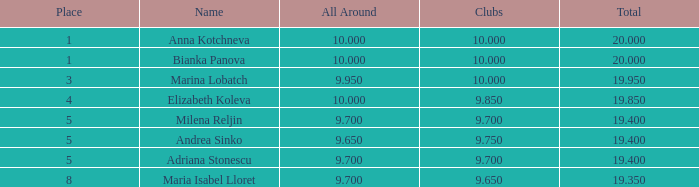Which are the least advanced clubs that hold a rank above 5 and possess an all-around score higher than 9.7? None. 